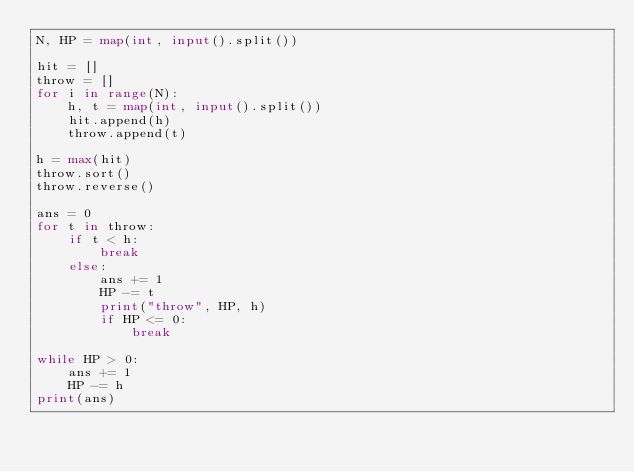<code> <loc_0><loc_0><loc_500><loc_500><_Python_>N, HP = map(int, input().split())

hit = []
throw = []
for i in range(N):
    h, t = map(int, input().split())
    hit.append(h)
    throw.append(t)

h = max(hit)
throw.sort()
throw.reverse()

ans = 0
for t in throw:
    if t < h:
        break
    else:
        ans += 1
        HP -= t
        print("throw", HP, h)
        if HP <= 0:
            break

while HP > 0:
    ans += 1
    HP -= h
print(ans)</code> 